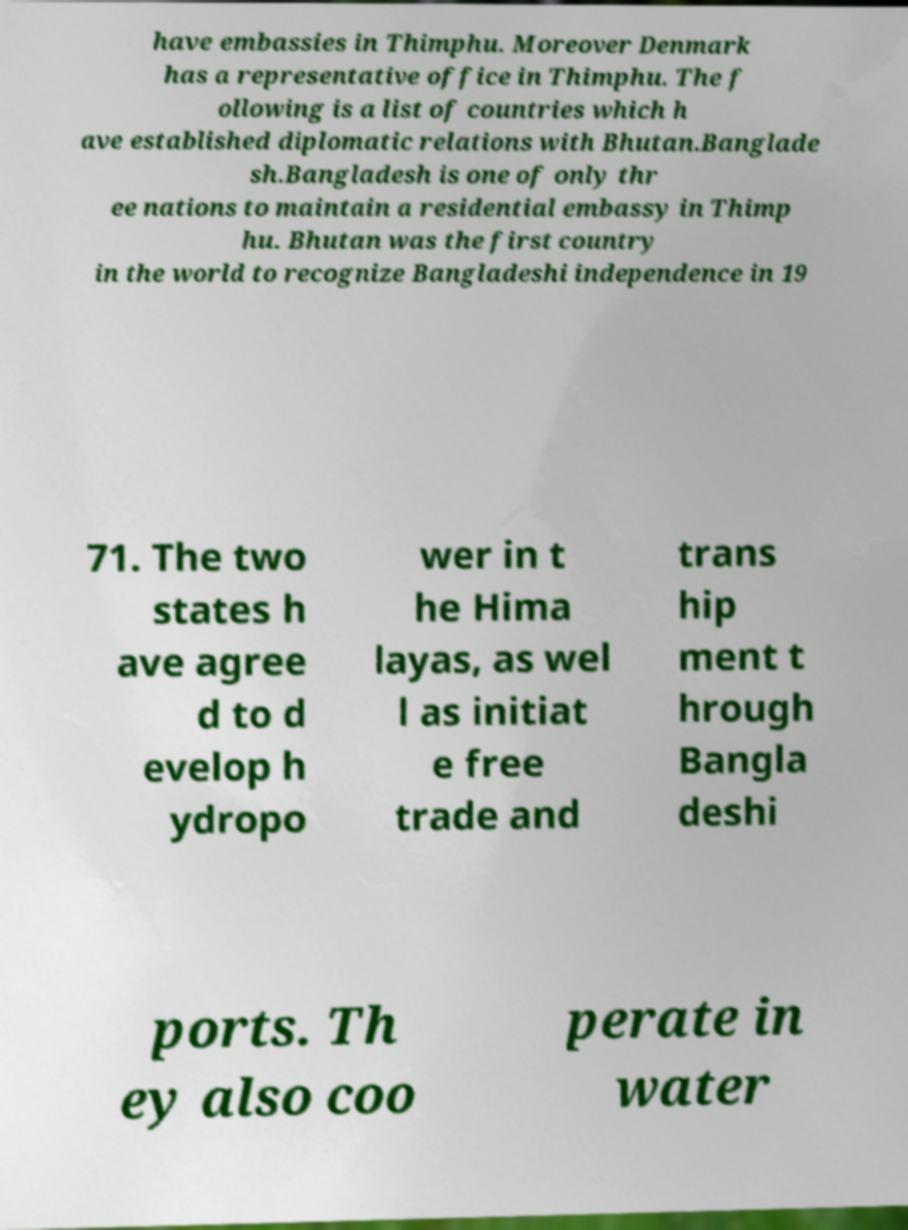Can you read and provide the text displayed in the image?This photo seems to have some interesting text. Can you extract and type it out for me? have embassies in Thimphu. Moreover Denmark has a representative office in Thimphu. The f ollowing is a list of countries which h ave established diplomatic relations with Bhutan.Banglade sh.Bangladesh is one of only thr ee nations to maintain a residential embassy in Thimp hu. Bhutan was the first country in the world to recognize Bangladeshi independence in 19 71. The two states h ave agree d to d evelop h ydropo wer in t he Hima layas, as wel l as initiat e free trade and trans hip ment t hrough Bangla deshi ports. Th ey also coo perate in water 